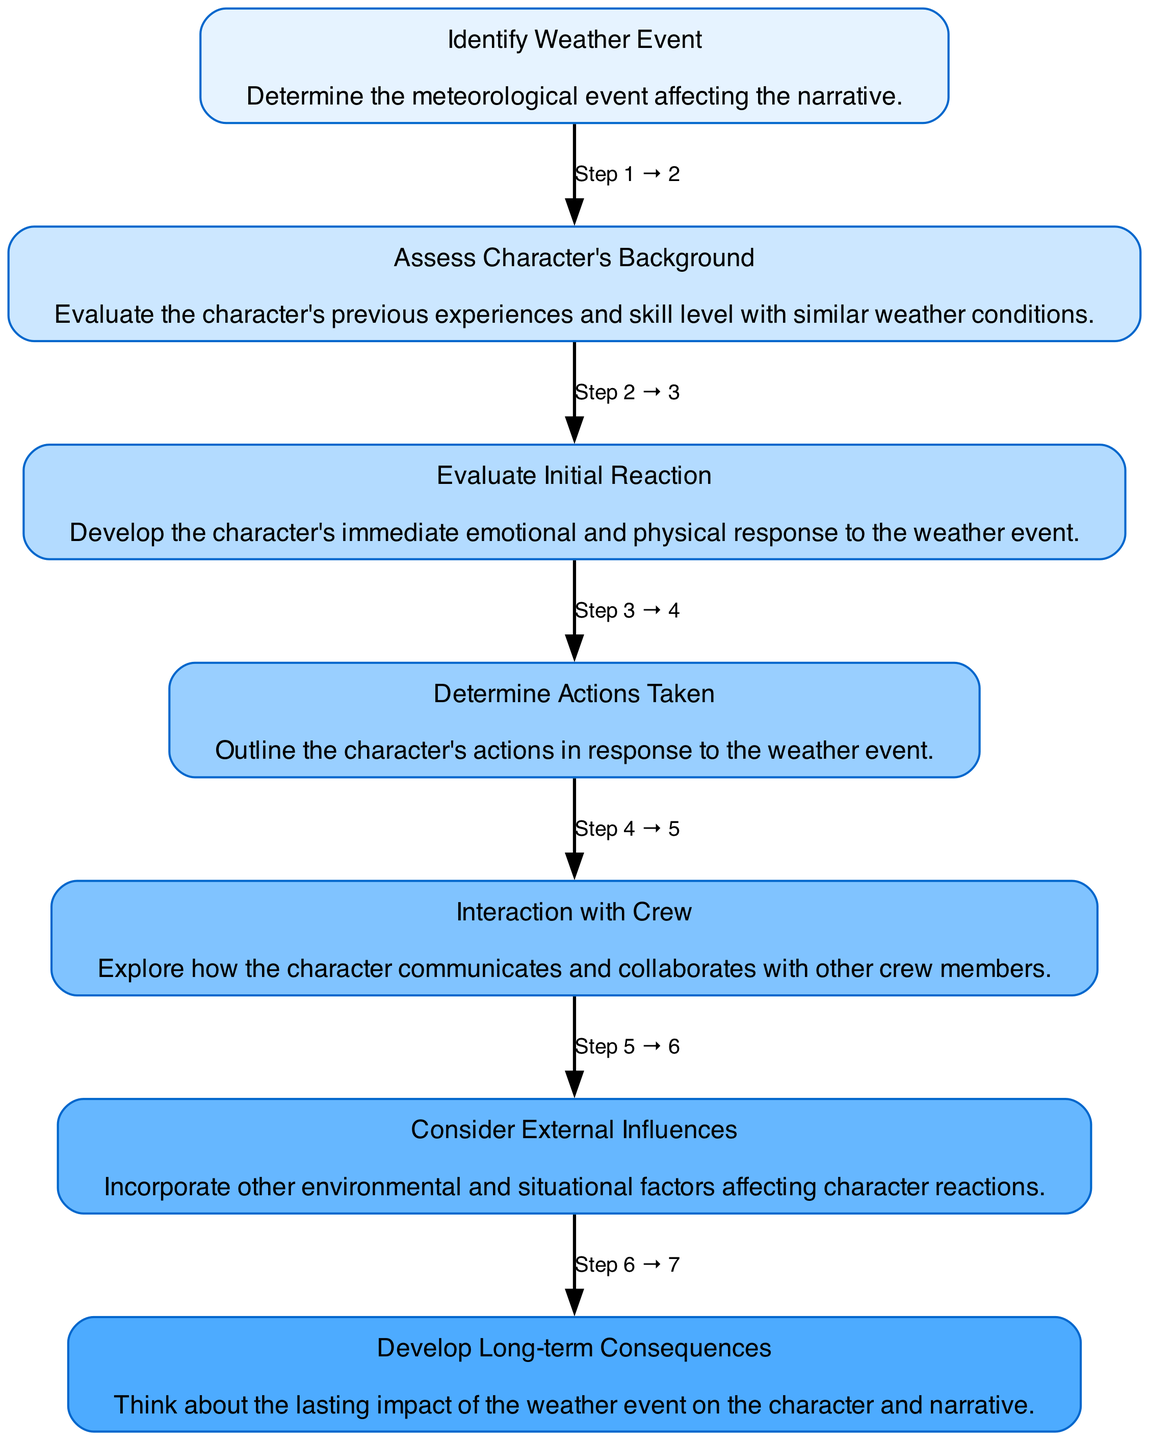What is the first step in the diagram? The first step in the diagram is "Identify Weather Event," which is the starting point of the process and indicates the need to determine the weather condition affecting the narrative.
Answer: Identify Weather Event How many actions are outlined in the diagram? There is a total of 5 actions listed in the "Determine Actions Taken" node that the character may undertake in response to the weather event.
Answer: 5 What is the last step in the flow chart? The last step is "Develop Long-term Consequences," which considers the lasting impacts of the weather event on the character and narrative progression.
Answer: Develop Long-term Consequences Which step discusses the character's immediate emotional and physical response? The step that discusses this is "Evaluate Initial Reaction," which focuses on developing how the character feels and reacts in the moment of the weather event.
Answer: Evaluate Initial Reaction What influences are considered in managing character reactions? The influences considered are "Time of day," "Location," and "Proximity to land," all of which can impact how a character responds to weather events at sea.
Answer: Time of day, Location, Proximity to land What does the diagram suggest a character should assess before responding to the weather event? Before responding to the weather event, the character should assess their background, which includes previous experiences and skill level with similar conditions.
Answer: Assess Character's Background How does the character's interaction with the crew fit into the flow? The character's interaction with the crew comes after determining actions taken, highlighting collaboration and communication during the weather event response.
Answer: Interaction with Crew What step follows after assessing the character's background? The step that follows after assessing the character's background is "Evaluate Initial Reaction," where the character's immediate reactions are developed.
Answer: Evaluate Initial Reaction 